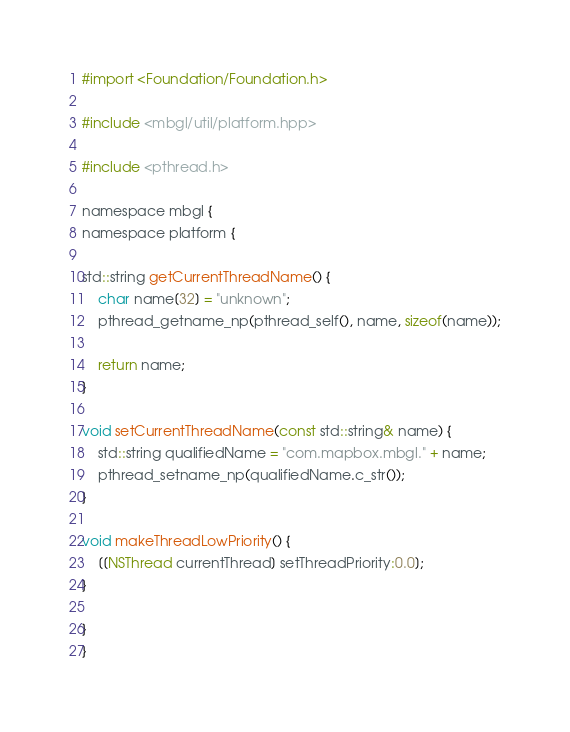Convert code to text. <code><loc_0><loc_0><loc_500><loc_500><_ObjectiveC_>#import <Foundation/Foundation.h>

#include <mbgl/util/platform.hpp>

#include <pthread.h>

namespace mbgl {
namespace platform {

std::string getCurrentThreadName() {
    char name[32] = "unknown";
    pthread_getname_np(pthread_self(), name, sizeof(name));

    return name;
}

void setCurrentThreadName(const std::string& name) {
    std::string qualifiedName = "com.mapbox.mbgl." + name;
    pthread_setname_np(qualifiedName.c_str());
}

void makeThreadLowPriority() {
    [[NSThread currentThread] setThreadPriority:0.0];
}

}
}
</code> 